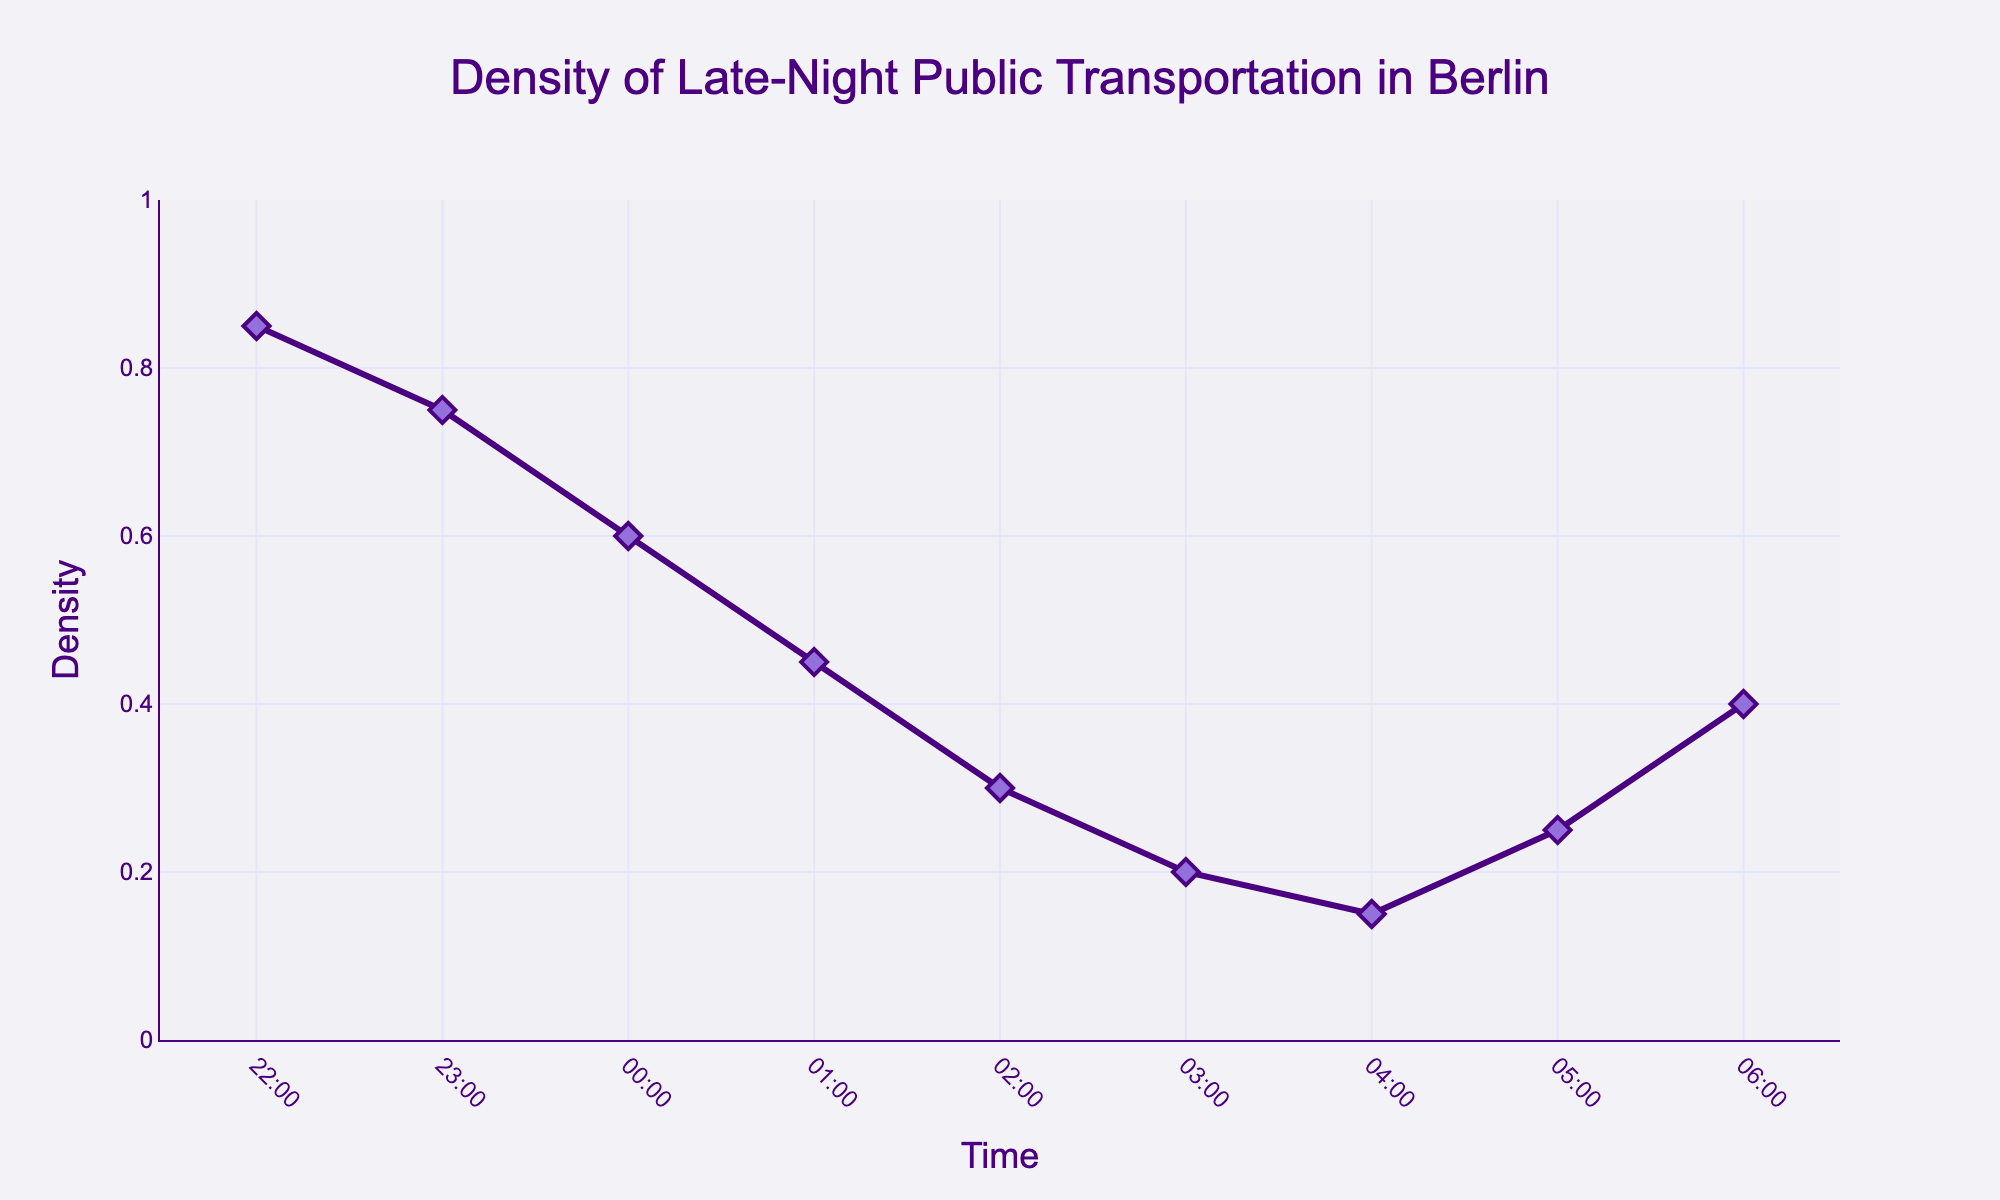What is the title of the figure? The title of the figure is usually placed at the top center. Upon inspection, the title is clearly indicated.
Answer: Density of Late-Night Public Transportation in Berlin What are the units on the x-axis? The units on the x-axis represent the different time intervals at which the density was measured. These are the specific hours from late night to early morning.
Answer: Time What color is used for the line in the plot? The coloring of the line can be identified by observing the color of the lines and markers in the figure.
Answer: Purple At what time is the density the highest? Reviewing the points along the y-axis and noting their values in relation to the time on the x-axis, identify the highest density value.
Answer: 22:00 Between which two consecutive hours is there the largest drop in density? Calculate the differences in density between each pair of consecutive hours and identify the pair with the largest difference. The drop is highest between 00:00 and 01:00.
Answer: 00:00 and 01:00 What is the density at 03:00? Find the data point corresponding to 03:00 on the x-axis and check its value on the y-axis.
Answer: 0.20 What is the time range where the density is below 0.3? Look for the time intervals on the x-axis where the density value on the y-axis is below 0.3. This occurs between 03:00 and 04:00.
Answer: 03:00 to 04:00 How does the density change from 04:00 to 06:00? Observe the density trend from 04:00 to 06:00 on the plot; the density starts at a lower point at 04:00, increases slightly at 05:00, and further rises at 06:00.
Answer: It increases What is the average density from 22:00 to 06:00? Sum the density values from 22:00 to 06:00 and divide by the total number of intervals (9). (0.85 + 0.75 + 0.60 + 0.45 + 0.30 + 0.20 + 0.15 + 0.25 + 0.40) / 9 = 0.441
Answer: 0.441 Which time interval has the least density? Locate the lowest point on the y-axis and identify the corresponding time interval on the x-axis.
Answer: 04:00 